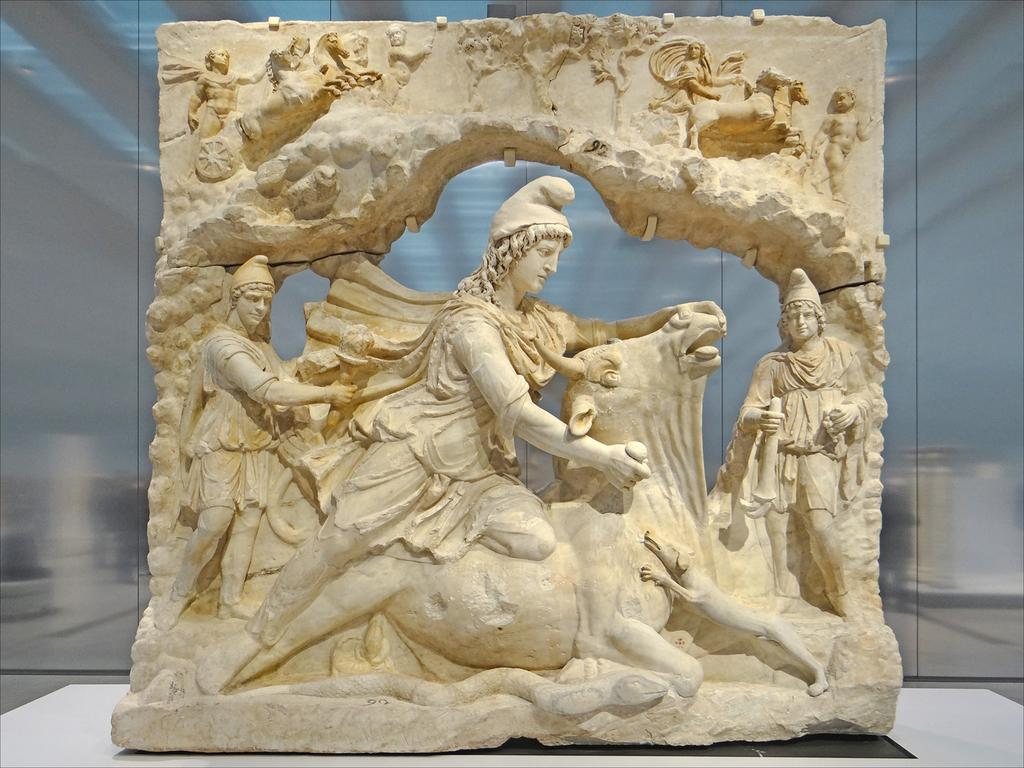What is the main subject in the image? There is a statue in the image. Where is the statue located? The statue is on a platform. What is the zephyr doing to the statue in the image? There is no zephyr present in the image, so it cannot be affecting the statue. 